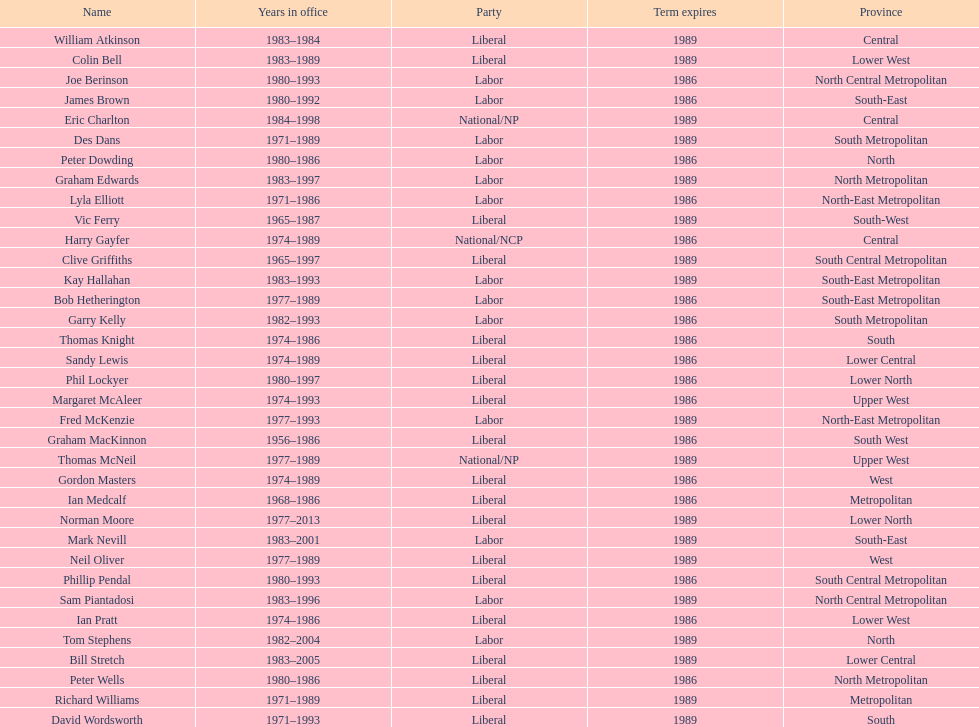Hame the last member listed whose last name begins with "p". Ian Pratt. 